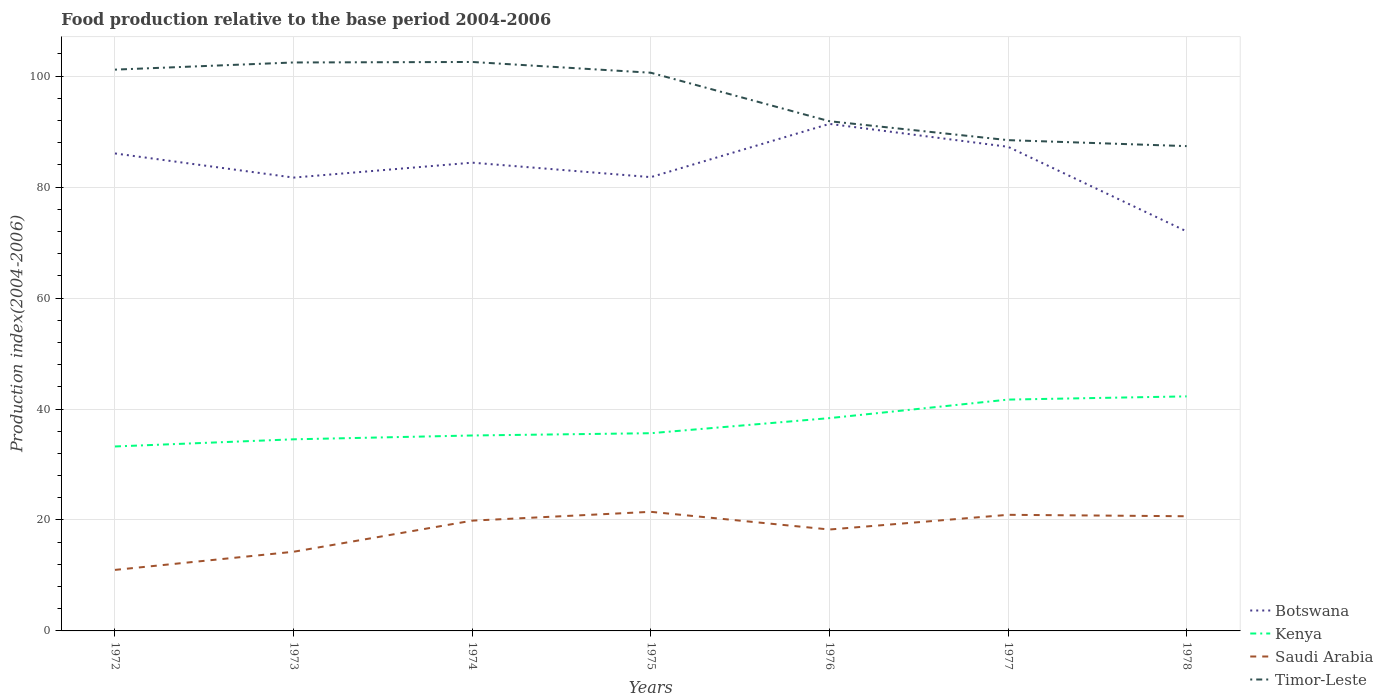Does the line corresponding to Botswana intersect with the line corresponding to Timor-Leste?
Provide a succinct answer. No. Across all years, what is the maximum food production index in Saudi Arabia?
Make the answer very short. 11. What is the total food production index in Saudi Arabia in the graph?
Provide a succinct answer. -0.79. What is the difference between the highest and the second highest food production index in Botswana?
Your answer should be very brief. 19.38. What is the difference between the highest and the lowest food production index in Kenya?
Make the answer very short. 3. Is the food production index in Botswana strictly greater than the food production index in Kenya over the years?
Your answer should be compact. No. What is the difference between two consecutive major ticks on the Y-axis?
Your answer should be compact. 20. Are the values on the major ticks of Y-axis written in scientific E-notation?
Provide a short and direct response. No. Does the graph contain any zero values?
Keep it short and to the point. No. What is the title of the graph?
Provide a succinct answer. Food production relative to the base period 2004-2006. What is the label or title of the Y-axis?
Make the answer very short. Production index(2004-2006). What is the Production index(2004-2006) of Botswana in 1972?
Provide a succinct answer. 86.07. What is the Production index(2004-2006) in Kenya in 1972?
Your response must be concise. 33.25. What is the Production index(2004-2006) in Saudi Arabia in 1972?
Your answer should be very brief. 11. What is the Production index(2004-2006) of Timor-Leste in 1972?
Your response must be concise. 101.18. What is the Production index(2004-2006) of Botswana in 1973?
Your answer should be compact. 81.72. What is the Production index(2004-2006) of Kenya in 1973?
Your response must be concise. 34.54. What is the Production index(2004-2006) of Saudi Arabia in 1973?
Provide a short and direct response. 14.27. What is the Production index(2004-2006) of Timor-Leste in 1973?
Give a very brief answer. 102.47. What is the Production index(2004-2006) of Botswana in 1974?
Provide a short and direct response. 84.41. What is the Production index(2004-2006) in Kenya in 1974?
Give a very brief answer. 35.23. What is the Production index(2004-2006) in Saudi Arabia in 1974?
Offer a terse response. 19.88. What is the Production index(2004-2006) in Timor-Leste in 1974?
Your response must be concise. 102.56. What is the Production index(2004-2006) in Botswana in 1975?
Make the answer very short. 81.8. What is the Production index(2004-2006) of Kenya in 1975?
Offer a very short reply. 35.64. What is the Production index(2004-2006) in Saudi Arabia in 1975?
Provide a succinct answer. 21.47. What is the Production index(2004-2006) in Timor-Leste in 1975?
Make the answer very short. 100.62. What is the Production index(2004-2006) in Botswana in 1976?
Provide a succinct answer. 91.4. What is the Production index(2004-2006) of Kenya in 1976?
Offer a very short reply. 38.36. What is the Production index(2004-2006) of Saudi Arabia in 1976?
Ensure brevity in your answer.  18.28. What is the Production index(2004-2006) in Timor-Leste in 1976?
Keep it short and to the point. 91.88. What is the Production index(2004-2006) in Botswana in 1977?
Give a very brief answer. 87.27. What is the Production index(2004-2006) in Kenya in 1977?
Ensure brevity in your answer.  41.7. What is the Production index(2004-2006) of Saudi Arabia in 1977?
Offer a very short reply. 20.93. What is the Production index(2004-2006) in Timor-Leste in 1977?
Provide a short and direct response. 88.47. What is the Production index(2004-2006) of Botswana in 1978?
Provide a short and direct response. 72.02. What is the Production index(2004-2006) in Kenya in 1978?
Offer a very short reply. 42.28. What is the Production index(2004-2006) in Saudi Arabia in 1978?
Keep it short and to the point. 20.67. What is the Production index(2004-2006) of Timor-Leste in 1978?
Make the answer very short. 87.39. Across all years, what is the maximum Production index(2004-2006) of Botswana?
Offer a terse response. 91.4. Across all years, what is the maximum Production index(2004-2006) in Kenya?
Your response must be concise. 42.28. Across all years, what is the maximum Production index(2004-2006) of Saudi Arabia?
Your answer should be compact. 21.47. Across all years, what is the maximum Production index(2004-2006) in Timor-Leste?
Keep it short and to the point. 102.56. Across all years, what is the minimum Production index(2004-2006) in Botswana?
Give a very brief answer. 72.02. Across all years, what is the minimum Production index(2004-2006) in Kenya?
Keep it short and to the point. 33.25. Across all years, what is the minimum Production index(2004-2006) of Timor-Leste?
Your answer should be compact. 87.39. What is the total Production index(2004-2006) in Botswana in the graph?
Keep it short and to the point. 584.69. What is the total Production index(2004-2006) in Kenya in the graph?
Offer a very short reply. 261. What is the total Production index(2004-2006) in Saudi Arabia in the graph?
Offer a terse response. 126.5. What is the total Production index(2004-2006) in Timor-Leste in the graph?
Offer a terse response. 674.57. What is the difference between the Production index(2004-2006) in Botswana in 1972 and that in 1973?
Ensure brevity in your answer.  4.35. What is the difference between the Production index(2004-2006) in Kenya in 1972 and that in 1973?
Your response must be concise. -1.29. What is the difference between the Production index(2004-2006) of Saudi Arabia in 1972 and that in 1973?
Provide a short and direct response. -3.27. What is the difference between the Production index(2004-2006) of Timor-Leste in 1972 and that in 1973?
Keep it short and to the point. -1.29. What is the difference between the Production index(2004-2006) in Botswana in 1972 and that in 1974?
Keep it short and to the point. 1.66. What is the difference between the Production index(2004-2006) of Kenya in 1972 and that in 1974?
Provide a short and direct response. -1.98. What is the difference between the Production index(2004-2006) in Saudi Arabia in 1972 and that in 1974?
Your response must be concise. -8.88. What is the difference between the Production index(2004-2006) of Timor-Leste in 1972 and that in 1974?
Give a very brief answer. -1.38. What is the difference between the Production index(2004-2006) in Botswana in 1972 and that in 1975?
Make the answer very short. 4.27. What is the difference between the Production index(2004-2006) in Kenya in 1972 and that in 1975?
Keep it short and to the point. -2.39. What is the difference between the Production index(2004-2006) in Saudi Arabia in 1972 and that in 1975?
Your answer should be very brief. -10.47. What is the difference between the Production index(2004-2006) in Timor-Leste in 1972 and that in 1975?
Ensure brevity in your answer.  0.56. What is the difference between the Production index(2004-2006) in Botswana in 1972 and that in 1976?
Your response must be concise. -5.33. What is the difference between the Production index(2004-2006) of Kenya in 1972 and that in 1976?
Keep it short and to the point. -5.11. What is the difference between the Production index(2004-2006) in Saudi Arabia in 1972 and that in 1976?
Provide a short and direct response. -7.28. What is the difference between the Production index(2004-2006) in Botswana in 1972 and that in 1977?
Your answer should be very brief. -1.2. What is the difference between the Production index(2004-2006) in Kenya in 1972 and that in 1977?
Offer a very short reply. -8.45. What is the difference between the Production index(2004-2006) of Saudi Arabia in 1972 and that in 1977?
Your answer should be compact. -9.93. What is the difference between the Production index(2004-2006) of Timor-Leste in 1972 and that in 1977?
Your answer should be very brief. 12.71. What is the difference between the Production index(2004-2006) of Botswana in 1972 and that in 1978?
Provide a succinct answer. 14.05. What is the difference between the Production index(2004-2006) of Kenya in 1972 and that in 1978?
Give a very brief answer. -9.03. What is the difference between the Production index(2004-2006) of Saudi Arabia in 1972 and that in 1978?
Your answer should be compact. -9.67. What is the difference between the Production index(2004-2006) of Timor-Leste in 1972 and that in 1978?
Make the answer very short. 13.79. What is the difference between the Production index(2004-2006) in Botswana in 1973 and that in 1974?
Offer a terse response. -2.69. What is the difference between the Production index(2004-2006) of Kenya in 1973 and that in 1974?
Offer a terse response. -0.69. What is the difference between the Production index(2004-2006) of Saudi Arabia in 1973 and that in 1974?
Offer a terse response. -5.61. What is the difference between the Production index(2004-2006) of Timor-Leste in 1973 and that in 1974?
Give a very brief answer. -0.09. What is the difference between the Production index(2004-2006) in Botswana in 1973 and that in 1975?
Offer a terse response. -0.08. What is the difference between the Production index(2004-2006) of Saudi Arabia in 1973 and that in 1975?
Provide a succinct answer. -7.2. What is the difference between the Production index(2004-2006) of Timor-Leste in 1973 and that in 1975?
Your response must be concise. 1.85. What is the difference between the Production index(2004-2006) of Botswana in 1973 and that in 1976?
Your answer should be compact. -9.68. What is the difference between the Production index(2004-2006) of Kenya in 1973 and that in 1976?
Ensure brevity in your answer.  -3.82. What is the difference between the Production index(2004-2006) in Saudi Arabia in 1973 and that in 1976?
Offer a very short reply. -4.01. What is the difference between the Production index(2004-2006) of Timor-Leste in 1973 and that in 1976?
Provide a succinct answer. 10.59. What is the difference between the Production index(2004-2006) in Botswana in 1973 and that in 1977?
Provide a succinct answer. -5.55. What is the difference between the Production index(2004-2006) of Kenya in 1973 and that in 1977?
Keep it short and to the point. -7.16. What is the difference between the Production index(2004-2006) of Saudi Arabia in 1973 and that in 1977?
Ensure brevity in your answer.  -6.66. What is the difference between the Production index(2004-2006) in Timor-Leste in 1973 and that in 1977?
Keep it short and to the point. 14. What is the difference between the Production index(2004-2006) of Botswana in 1973 and that in 1978?
Provide a short and direct response. 9.7. What is the difference between the Production index(2004-2006) in Kenya in 1973 and that in 1978?
Keep it short and to the point. -7.74. What is the difference between the Production index(2004-2006) of Saudi Arabia in 1973 and that in 1978?
Offer a very short reply. -6.4. What is the difference between the Production index(2004-2006) of Timor-Leste in 1973 and that in 1978?
Provide a short and direct response. 15.08. What is the difference between the Production index(2004-2006) in Botswana in 1974 and that in 1975?
Provide a short and direct response. 2.61. What is the difference between the Production index(2004-2006) of Kenya in 1974 and that in 1975?
Offer a terse response. -0.41. What is the difference between the Production index(2004-2006) in Saudi Arabia in 1974 and that in 1975?
Your answer should be compact. -1.59. What is the difference between the Production index(2004-2006) in Timor-Leste in 1974 and that in 1975?
Give a very brief answer. 1.94. What is the difference between the Production index(2004-2006) in Botswana in 1974 and that in 1976?
Your answer should be compact. -6.99. What is the difference between the Production index(2004-2006) in Kenya in 1974 and that in 1976?
Your response must be concise. -3.13. What is the difference between the Production index(2004-2006) in Timor-Leste in 1974 and that in 1976?
Give a very brief answer. 10.68. What is the difference between the Production index(2004-2006) in Botswana in 1974 and that in 1977?
Provide a succinct answer. -2.86. What is the difference between the Production index(2004-2006) of Kenya in 1974 and that in 1977?
Provide a short and direct response. -6.47. What is the difference between the Production index(2004-2006) of Saudi Arabia in 1974 and that in 1977?
Provide a succinct answer. -1.05. What is the difference between the Production index(2004-2006) of Timor-Leste in 1974 and that in 1977?
Provide a short and direct response. 14.09. What is the difference between the Production index(2004-2006) in Botswana in 1974 and that in 1978?
Offer a very short reply. 12.39. What is the difference between the Production index(2004-2006) of Kenya in 1974 and that in 1978?
Your response must be concise. -7.05. What is the difference between the Production index(2004-2006) of Saudi Arabia in 1974 and that in 1978?
Offer a terse response. -0.79. What is the difference between the Production index(2004-2006) in Timor-Leste in 1974 and that in 1978?
Keep it short and to the point. 15.17. What is the difference between the Production index(2004-2006) of Kenya in 1975 and that in 1976?
Offer a terse response. -2.72. What is the difference between the Production index(2004-2006) of Saudi Arabia in 1975 and that in 1976?
Your answer should be compact. 3.19. What is the difference between the Production index(2004-2006) in Timor-Leste in 1975 and that in 1976?
Give a very brief answer. 8.74. What is the difference between the Production index(2004-2006) of Botswana in 1975 and that in 1977?
Keep it short and to the point. -5.47. What is the difference between the Production index(2004-2006) of Kenya in 1975 and that in 1977?
Your answer should be compact. -6.06. What is the difference between the Production index(2004-2006) of Saudi Arabia in 1975 and that in 1977?
Offer a very short reply. 0.54. What is the difference between the Production index(2004-2006) of Timor-Leste in 1975 and that in 1977?
Ensure brevity in your answer.  12.15. What is the difference between the Production index(2004-2006) of Botswana in 1975 and that in 1978?
Provide a short and direct response. 9.78. What is the difference between the Production index(2004-2006) in Kenya in 1975 and that in 1978?
Ensure brevity in your answer.  -6.64. What is the difference between the Production index(2004-2006) in Saudi Arabia in 1975 and that in 1978?
Keep it short and to the point. 0.8. What is the difference between the Production index(2004-2006) of Timor-Leste in 1975 and that in 1978?
Keep it short and to the point. 13.23. What is the difference between the Production index(2004-2006) of Botswana in 1976 and that in 1977?
Make the answer very short. 4.13. What is the difference between the Production index(2004-2006) of Kenya in 1976 and that in 1977?
Offer a terse response. -3.34. What is the difference between the Production index(2004-2006) in Saudi Arabia in 1976 and that in 1977?
Offer a terse response. -2.65. What is the difference between the Production index(2004-2006) of Timor-Leste in 1976 and that in 1977?
Offer a terse response. 3.41. What is the difference between the Production index(2004-2006) in Botswana in 1976 and that in 1978?
Offer a very short reply. 19.38. What is the difference between the Production index(2004-2006) of Kenya in 1976 and that in 1978?
Your response must be concise. -3.92. What is the difference between the Production index(2004-2006) in Saudi Arabia in 1976 and that in 1978?
Make the answer very short. -2.39. What is the difference between the Production index(2004-2006) of Timor-Leste in 1976 and that in 1978?
Ensure brevity in your answer.  4.49. What is the difference between the Production index(2004-2006) in Botswana in 1977 and that in 1978?
Your response must be concise. 15.25. What is the difference between the Production index(2004-2006) of Kenya in 1977 and that in 1978?
Ensure brevity in your answer.  -0.58. What is the difference between the Production index(2004-2006) of Saudi Arabia in 1977 and that in 1978?
Provide a short and direct response. 0.26. What is the difference between the Production index(2004-2006) in Timor-Leste in 1977 and that in 1978?
Provide a succinct answer. 1.08. What is the difference between the Production index(2004-2006) in Botswana in 1972 and the Production index(2004-2006) in Kenya in 1973?
Provide a short and direct response. 51.53. What is the difference between the Production index(2004-2006) of Botswana in 1972 and the Production index(2004-2006) of Saudi Arabia in 1973?
Your response must be concise. 71.8. What is the difference between the Production index(2004-2006) in Botswana in 1972 and the Production index(2004-2006) in Timor-Leste in 1973?
Your answer should be very brief. -16.4. What is the difference between the Production index(2004-2006) of Kenya in 1972 and the Production index(2004-2006) of Saudi Arabia in 1973?
Keep it short and to the point. 18.98. What is the difference between the Production index(2004-2006) in Kenya in 1972 and the Production index(2004-2006) in Timor-Leste in 1973?
Provide a succinct answer. -69.22. What is the difference between the Production index(2004-2006) of Saudi Arabia in 1972 and the Production index(2004-2006) of Timor-Leste in 1973?
Keep it short and to the point. -91.47. What is the difference between the Production index(2004-2006) of Botswana in 1972 and the Production index(2004-2006) of Kenya in 1974?
Provide a short and direct response. 50.84. What is the difference between the Production index(2004-2006) in Botswana in 1972 and the Production index(2004-2006) in Saudi Arabia in 1974?
Provide a succinct answer. 66.19. What is the difference between the Production index(2004-2006) in Botswana in 1972 and the Production index(2004-2006) in Timor-Leste in 1974?
Offer a very short reply. -16.49. What is the difference between the Production index(2004-2006) of Kenya in 1972 and the Production index(2004-2006) of Saudi Arabia in 1974?
Your response must be concise. 13.37. What is the difference between the Production index(2004-2006) of Kenya in 1972 and the Production index(2004-2006) of Timor-Leste in 1974?
Offer a terse response. -69.31. What is the difference between the Production index(2004-2006) in Saudi Arabia in 1972 and the Production index(2004-2006) in Timor-Leste in 1974?
Your response must be concise. -91.56. What is the difference between the Production index(2004-2006) of Botswana in 1972 and the Production index(2004-2006) of Kenya in 1975?
Ensure brevity in your answer.  50.43. What is the difference between the Production index(2004-2006) in Botswana in 1972 and the Production index(2004-2006) in Saudi Arabia in 1975?
Offer a very short reply. 64.6. What is the difference between the Production index(2004-2006) in Botswana in 1972 and the Production index(2004-2006) in Timor-Leste in 1975?
Your answer should be very brief. -14.55. What is the difference between the Production index(2004-2006) in Kenya in 1972 and the Production index(2004-2006) in Saudi Arabia in 1975?
Provide a short and direct response. 11.78. What is the difference between the Production index(2004-2006) of Kenya in 1972 and the Production index(2004-2006) of Timor-Leste in 1975?
Your response must be concise. -67.37. What is the difference between the Production index(2004-2006) of Saudi Arabia in 1972 and the Production index(2004-2006) of Timor-Leste in 1975?
Provide a succinct answer. -89.62. What is the difference between the Production index(2004-2006) of Botswana in 1972 and the Production index(2004-2006) of Kenya in 1976?
Provide a short and direct response. 47.71. What is the difference between the Production index(2004-2006) in Botswana in 1972 and the Production index(2004-2006) in Saudi Arabia in 1976?
Your response must be concise. 67.79. What is the difference between the Production index(2004-2006) in Botswana in 1972 and the Production index(2004-2006) in Timor-Leste in 1976?
Your answer should be very brief. -5.81. What is the difference between the Production index(2004-2006) in Kenya in 1972 and the Production index(2004-2006) in Saudi Arabia in 1976?
Make the answer very short. 14.97. What is the difference between the Production index(2004-2006) in Kenya in 1972 and the Production index(2004-2006) in Timor-Leste in 1976?
Give a very brief answer. -58.63. What is the difference between the Production index(2004-2006) in Saudi Arabia in 1972 and the Production index(2004-2006) in Timor-Leste in 1976?
Give a very brief answer. -80.88. What is the difference between the Production index(2004-2006) in Botswana in 1972 and the Production index(2004-2006) in Kenya in 1977?
Make the answer very short. 44.37. What is the difference between the Production index(2004-2006) in Botswana in 1972 and the Production index(2004-2006) in Saudi Arabia in 1977?
Make the answer very short. 65.14. What is the difference between the Production index(2004-2006) in Kenya in 1972 and the Production index(2004-2006) in Saudi Arabia in 1977?
Make the answer very short. 12.32. What is the difference between the Production index(2004-2006) in Kenya in 1972 and the Production index(2004-2006) in Timor-Leste in 1977?
Provide a succinct answer. -55.22. What is the difference between the Production index(2004-2006) of Saudi Arabia in 1972 and the Production index(2004-2006) of Timor-Leste in 1977?
Your answer should be very brief. -77.47. What is the difference between the Production index(2004-2006) in Botswana in 1972 and the Production index(2004-2006) in Kenya in 1978?
Your response must be concise. 43.79. What is the difference between the Production index(2004-2006) of Botswana in 1972 and the Production index(2004-2006) of Saudi Arabia in 1978?
Ensure brevity in your answer.  65.4. What is the difference between the Production index(2004-2006) in Botswana in 1972 and the Production index(2004-2006) in Timor-Leste in 1978?
Offer a terse response. -1.32. What is the difference between the Production index(2004-2006) in Kenya in 1972 and the Production index(2004-2006) in Saudi Arabia in 1978?
Your answer should be very brief. 12.58. What is the difference between the Production index(2004-2006) in Kenya in 1972 and the Production index(2004-2006) in Timor-Leste in 1978?
Provide a short and direct response. -54.14. What is the difference between the Production index(2004-2006) in Saudi Arabia in 1972 and the Production index(2004-2006) in Timor-Leste in 1978?
Your answer should be compact. -76.39. What is the difference between the Production index(2004-2006) of Botswana in 1973 and the Production index(2004-2006) of Kenya in 1974?
Give a very brief answer. 46.49. What is the difference between the Production index(2004-2006) in Botswana in 1973 and the Production index(2004-2006) in Saudi Arabia in 1974?
Ensure brevity in your answer.  61.84. What is the difference between the Production index(2004-2006) in Botswana in 1973 and the Production index(2004-2006) in Timor-Leste in 1974?
Provide a short and direct response. -20.84. What is the difference between the Production index(2004-2006) of Kenya in 1973 and the Production index(2004-2006) of Saudi Arabia in 1974?
Your response must be concise. 14.66. What is the difference between the Production index(2004-2006) in Kenya in 1973 and the Production index(2004-2006) in Timor-Leste in 1974?
Offer a very short reply. -68.02. What is the difference between the Production index(2004-2006) of Saudi Arabia in 1973 and the Production index(2004-2006) of Timor-Leste in 1974?
Your answer should be compact. -88.29. What is the difference between the Production index(2004-2006) in Botswana in 1973 and the Production index(2004-2006) in Kenya in 1975?
Give a very brief answer. 46.08. What is the difference between the Production index(2004-2006) in Botswana in 1973 and the Production index(2004-2006) in Saudi Arabia in 1975?
Offer a very short reply. 60.25. What is the difference between the Production index(2004-2006) of Botswana in 1973 and the Production index(2004-2006) of Timor-Leste in 1975?
Your answer should be compact. -18.9. What is the difference between the Production index(2004-2006) of Kenya in 1973 and the Production index(2004-2006) of Saudi Arabia in 1975?
Give a very brief answer. 13.07. What is the difference between the Production index(2004-2006) in Kenya in 1973 and the Production index(2004-2006) in Timor-Leste in 1975?
Keep it short and to the point. -66.08. What is the difference between the Production index(2004-2006) in Saudi Arabia in 1973 and the Production index(2004-2006) in Timor-Leste in 1975?
Your answer should be very brief. -86.35. What is the difference between the Production index(2004-2006) of Botswana in 1973 and the Production index(2004-2006) of Kenya in 1976?
Your answer should be compact. 43.36. What is the difference between the Production index(2004-2006) of Botswana in 1973 and the Production index(2004-2006) of Saudi Arabia in 1976?
Offer a terse response. 63.44. What is the difference between the Production index(2004-2006) of Botswana in 1973 and the Production index(2004-2006) of Timor-Leste in 1976?
Your answer should be compact. -10.16. What is the difference between the Production index(2004-2006) of Kenya in 1973 and the Production index(2004-2006) of Saudi Arabia in 1976?
Provide a short and direct response. 16.26. What is the difference between the Production index(2004-2006) in Kenya in 1973 and the Production index(2004-2006) in Timor-Leste in 1976?
Make the answer very short. -57.34. What is the difference between the Production index(2004-2006) in Saudi Arabia in 1973 and the Production index(2004-2006) in Timor-Leste in 1976?
Provide a succinct answer. -77.61. What is the difference between the Production index(2004-2006) in Botswana in 1973 and the Production index(2004-2006) in Kenya in 1977?
Your answer should be very brief. 40.02. What is the difference between the Production index(2004-2006) in Botswana in 1973 and the Production index(2004-2006) in Saudi Arabia in 1977?
Ensure brevity in your answer.  60.79. What is the difference between the Production index(2004-2006) of Botswana in 1973 and the Production index(2004-2006) of Timor-Leste in 1977?
Make the answer very short. -6.75. What is the difference between the Production index(2004-2006) of Kenya in 1973 and the Production index(2004-2006) of Saudi Arabia in 1977?
Provide a succinct answer. 13.61. What is the difference between the Production index(2004-2006) of Kenya in 1973 and the Production index(2004-2006) of Timor-Leste in 1977?
Ensure brevity in your answer.  -53.93. What is the difference between the Production index(2004-2006) in Saudi Arabia in 1973 and the Production index(2004-2006) in Timor-Leste in 1977?
Provide a succinct answer. -74.2. What is the difference between the Production index(2004-2006) in Botswana in 1973 and the Production index(2004-2006) in Kenya in 1978?
Your answer should be compact. 39.44. What is the difference between the Production index(2004-2006) in Botswana in 1973 and the Production index(2004-2006) in Saudi Arabia in 1978?
Provide a succinct answer. 61.05. What is the difference between the Production index(2004-2006) of Botswana in 1973 and the Production index(2004-2006) of Timor-Leste in 1978?
Make the answer very short. -5.67. What is the difference between the Production index(2004-2006) of Kenya in 1973 and the Production index(2004-2006) of Saudi Arabia in 1978?
Provide a short and direct response. 13.87. What is the difference between the Production index(2004-2006) in Kenya in 1973 and the Production index(2004-2006) in Timor-Leste in 1978?
Your answer should be very brief. -52.85. What is the difference between the Production index(2004-2006) in Saudi Arabia in 1973 and the Production index(2004-2006) in Timor-Leste in 1978?
Make the answer very short. -73.12. What is the difference between the Production index(2004-2006) in Botswana in 1974 and the Production index(2004-2006) in Kenya in 1975?
Provide a succinct answer. 48.77. What is the difference between the Production index(2004-2006) of Botswana in 1974 and the Production index(2004-2006) of Saudi Arabia in 1975?
Your answer should be very brief. 62.94. What is the difference between the Production index(2004-2006) in Botswana in 1974 and the Production index(2004-2006) in Timor-Leste in 1975?
Ensure brevity in your answer.  -16.21. What is the difference between the Production index(2004-2006) in Kenya in 1974 and the Production index(2004-2006) in Saudi Arabia in 1975?
Provide a succinct answer. 13.76. What is the difference between the Production index(2004-2006) in Kenya in 1974 and the Production index(2004-2006) in Timor-Leste in 1975?
Give a very brief answer. -65.39. What is the difference between the Production index(2004-2006) in Saudi Arabia in 1974 and the Production index(2004-2006) in Timor-Leste in 1975?
Your answer should be very brief. -80.74. What is the difference between the Production index(2004-2006) of Botswana in 1974 and the Production index(2004-2006) of Kenya in 1976?
Offer a very short reply. 46.05. What is the difference between the Production index(2004-2006) in Botswana in 1974 and the Production index(2004-2006) in Saudi Arabia in 1976?
Offer a very short reply. 66.13. What is the difference between the Production index(2004-2006) in Botswana in 1974 and the Production index(2004-2006) in Timor-Leste in 1976?
Keep it short and to the point. -7.47. What is the difference between the Production index(2004-2006) of Kenya in 1974 and the Production index(2004-2006) of Saudi Arabia in 1976?
Offer a terse response. 16.95. What is the difference between the Production index(2004-2006) of Kenya in 1974 and the Production index(2004-2006) of Timor-Leste in 1976?
Give a very brief answer. -56.65. What is the difference between the Production index(2004-2006) of Saudi Arabia in 1974 and the Production index(2004-2006) of Timor-Leste in 1976?
Offer a very short reply. -72. What is the difference between the Production index(2004-2006) of Botswana in 1974 and the Production index(2004-2006) of Kenya in 1977?
Provide a succinct answer. 42.71. What is the difference between the Production index(2004-2006) of Botswana in 1974 and the Production index(2004-2006) of Saudi Arabia in 1977?
Your answer should be very brief. 63.48. What is the difference between the Production index(2004-2006) of Botswana in 1974 and the Production index(2004-2006) of Timor-Leste in 1977?
Provide a short and direct response. -4.06. What is the difference between the Production index(2004-2006) in Kenya in 1974 and the Production index(2004-2006) in Saudi Arabia in 1977?
Keep it short and to the point. 14.3. What is the difference between the Production index(2004-2006) in Kenya in 1974 and the Production index(2004-2006) in Timor-Leste in 1977?
Ensure brevity in your answer.  -53.24. What is the difference between the Production index(2004-2006) of Saudi Arabia in 1974 and the Production index(2004-2006) of Timor-Leste in 1977?
Give a very brief answer. -68.59. What is the difference between the Production index(2004-2006) in Botswana in 1974 and the Production index(2004-2006) in Kenya in 1978?
Offer a very short reply. 42.13. What is the difference between the Production index(2004-2006) of Botswana in 1974 and the Production index(2004-2006) of Saudi Arabia in 1978?
Provide a short and direct response. 63.74. What is the difference between the Production index(2004-2006) in Botswana in 1974 and the Production index(2004-2006) in Timor-Leste in 1978?
Make the answer very short. -2.98. What is the difference between the Production index(2004-2006) of Kenya in 1974 and the Production index(2004-2006) of Saudi Arabia in 1978?
Ensure brevity in your answer.  14.56. What is the difference between the Production index(2004-2006) of Kenya in 1974 and the Production index(2004-2006) of Timor-Leste in 1978?
Your response must be concise. -52.16. What is the difference between the Production index(2004-2006) of Saudi Arabia in 1974 and the Production index(2004-2006) of Timor-Leste in 1978?
Provide a succinct answer. -67.51. What is the difference between the Production index(2004-2006) of Botswana in 1975 and the Production index(2004-2006) of Kenya in 1976?
Offer a terse response. 43.44. What is the difference between the Production index(2004-2006) in Botswana in 1975 and the Production index(2004-2006) in Saudi Arabia in 1976?
Provide a short and direct response. 63.52. What is the difference between the Production index(2004-2006) in Botswana in 1975 and the Production index(2004-2006) in Timor-Leste in 1976?
Provide a succinct answer. -10.08. What is the difference between the Production index(2004-2006) of Kenya in 1975 and the Production index(2004-2006) of Saudi Arabia in 1976?
Provide a short and direct response. 17.36. What is the difference between the Production index(2004-2006) of Kenya in 1975 and the Production index(2004-2006) of Timor-Leste in 1976?
Provide a short and direct response. -56.24. What is the difference between the Production index(2004-2006) of Saudi Arabia in 1975 and the Production index(2004-2006) of Timor-Leste in 1976?
Give a very brief answer. -70.41. What is the difference between the Production index(2004-2006) of Botswana in 1975 and the Production index(2004-2006) of Kenya in 1977?
Ensure brevity in your answer.  40.1. What is the difference between the Production index(2004-2006) of Botswana in 1975 and the Production index(2004-2006) of Saudi Arabia in 1977?
Offer a terse response. 60.87. What is the difference between the Production index(2004-2006) in Botswana in 1975 and the Production index(2004-2006) in Timor-Leste in 1977?
Offer a very short reply. -6.67. What is the difference between the Production index(2004-2006) of Kenya in 1975 and the Production index(2004-2006) of Saudi Arabia in 1977?
Your answer should be compact. 14.71. What is the difference between the Production index(2004-2006) of Kenya in 1975 and the Production index(2004-2006) of Timor-Leste in 1977?
Make the answer very short. -52.83. What is the difference between the Production index(2004-2006) of Saudi Arabia in 1975 and the Production index(2004-2006) of Timor-Leste in 1977?
Make the answer very short. -67. What is the difference between the Production index(2004-2006) of Botswana in 1975 and the Production index(2004-2006) of Kenya in 1978?
Keep it short and to the point. 39.52. What is the difference between the Production index(2004-2006) of Botswana in 1975 and the Production index(2004-2006) of Saudi Arabia in 1978?
Your answer should be very brief. 61.13. What is the difference between the Production index(2004-2006) of Botswana in 1975 and the Production index(2004-2006) of Timor-Leste in 1978?
Your answer should be very brief. -5.59. What is the difference between the Production index(2004-2006) of Kenya in 1975 and the Production index(2004-2006) of Saudi Arabia in 1978?
Provide a succinct answer. 14.97. What is the difference between the Production index(2004-2006) of Kenya in 1975 and the Production index(2004-2006) of Timor-Leste in 1978?
Your answer should be compact. -51.75. What is the difference between the Production index(2004-2006) of Saudi Arabia in 1975 and the Production index(2004-2006) of Timor-Leste in 1978?
Provide a short and direct response. -65.92. What is the difference between the Production index(2004-2006) of Botswana in 1976 and the Production index(2004-2006) of Kenya in 1977?
Provide a succinct answer. 49.7. What is the difference between the Production index(2004-2006) of Botswana in 1976 and the Production index(2004-2006) of Saudi Arabia in 1977?
Ensure brevity in your answer.  70.47. What is the difference between the Production index(2004-2006) of Botswana in 1976 and the Production index(2004-2006) of Timor-Leste in 1977?
Ensure brevity in your answer.  2.93. What is the difference between the Production index(2004-2006) of Kenya in 1976 and the Production index(2004-2006) of Saudi Arabia in 1977?
Your answer should be very brief. 17.43. What is the difference between the Production index(2004-2006) of Kenya in 1976 and the Production index(2004-2006) of Timor-Leste in 1977?
Offer a terse response. -50.11. What is the difference between the Production index(2004-2006) of Saudi Arabia in 1976 and the Production index(2004-2006) of Timor-Leste in 1977?
Provide a succinct answer. -70.19. What is the difference between the Production index(2004-2006) of Botswana in 1976 and the Production index(2004-2006) of Kenya in 1978?
Your response must be concise. 49.12. What is the difference between the Production index(2004-2006) in Botswana in 1976 and the Production index(2004-2006) in Saudi Arabia in 1978?
Give a very brief answer. 70.73. What is the difference between the Production index(2004-2006) in Botswana in 1976 and the Production index(2004-2006) in Timor-Leste in 1978?
Provide a succinct answer. 4.01. What is the difference between the Production index(2004-2006) of Kenya in 1976 and the Production index(2004-2006) of Saudi Arabia in 1978?
Keep it short and to the point. 17.69. What is the difference between the Production index(2004-2006) of Kenya in 1976 and the Production index(2004-2006) of Timor-Leste in 1978?
Your response must be concise. -49.03. What is the difference between the Production index(2004-2006) in Saudi Arabia in 1976 and the Production index(2004-2006) in Timor-Leste in 1978?
Give a very brief answer. -69.11. What is the difference between the Production index(2004-2006) of Botswana in 1977 and the Production index(2004-2006) of Kenya in 1978?
Your answer should be compact. 44.99. What is the difference between the Production index(2004-2006) of Botswana in 1977 and the Production index(2004-2006) of Saudi Arabia in 1978?
Your answer should be compact. 66.6. What is the difference between the Production index(2004-2006) in Botswana in 1977 and the Production index(2004-2006) in Timor-Leste in 1978?
Your answer should be compact. -0.12. What is the difference between the Production index(2004-2006) in Kenya in 1977 and the Production index(2004-2006) in Saudi Arabia in 1978?
Offer a very short reply. 21.03. What is the difference between the Production index(2004-2006) of Kenya in 1977 and the Production index(2004-2006) of Timor-Leste in 1978?
Keep it short and to the point. -45.69. What is the difference between the Production index(2004-2006) of Saudi Arabia in 1977 and the Production index(2004-2006) of Timor-Leste in 1978?
Make the answer very short. -66.46. What is the average Production index(2004-2006) in Botswana per year?
Make the answer very short. 83.53. What is the average Production index(2004-2006) of Kenya per year?
Ensure brevity in your answer.  37.29. What is the average Production index(2004-2006) in Saudi Arabia per year?
Offer a terse response. 18.07. What is the average Production index(2004-2006) of Timor-Leste per year?
Ensure brevity in your answer.  96.37. In the year 1972, what is the difference between the Production index(2004-2006) in Botswana and Production index(2004-2006) in Kenya?
Ensure brevity in your answer.  52.82. In the year 1972, what is the difference between the Production index(2004-2006) of Botswana and Production index(2004-2006) of Saudi Arabia?
Make the answer very short. 75.07. In the year 1972, what is the difference between the Production index(2004-2006) in Botswana and Production index(2004-2006) in Timor-Leste?
Give a very brief answer. -15.11. In the year 1972, what is the difference between the Production index(2004-2006) of Kenya and Production index(2004-2006) of Saudi Arabia?
Offer a terse response. 22.25. In the year 1972, what is the difference between the Production index(2004-2006) of Kenya and Production index(2004-2006) of Timor-Leste?
Your response must be concise. -67.93. In the year 1972, what is the difference between the Production index(2004-2006) in Saudi Arabia and Production index(2004-2006) in Timor-Leste?
Provide a succinct answer. -90.18. In the year 1973, what is the difference between the Production index(2004-2006) in Botswana and Production index(2004-2006) in Kenya?
Your answer should be very brief. 47.18. In the year 1973, what is the difference between the Production index(2004-2006) of Botswana and Production index(2004-2006) of Saudi Arabia?
Ensure brevity in your answer.  67.45. In the year 1973, what is the difference between the Production index(2004-2006) in Botswana and Production index(2004-2006) in Timor-Leste?
Give a very brief answer. -20.75. In the year 1973, what is the difference between the Production index(2004-2006) of Kenya and Production index(2004-2006) of Saudi Arabia?
Keep it short and to the point. 20.27. In the year 1973, what is the difference between the Production index(2004-2006) in Kenya and Production index(2004-2006) in Timor-Leste?
Keep it short and to the point. -67.93. In the year 1973, what is the difference between the Production index(2004-2006) in Saudi Arabia and Production index(2004-2006) in Timor-Leste?
Your answer should be compact. -88.2. In the year 1974, what is the difference between the Production index(2004-2006) in Botswana and Production index(2004-2006) in Kenya?
Your answer should be compact. 49.18. In the year 1974, what is the difference between the Production index(2004-2006) of Botswana and Production index(2004-2006) of Saudi Arabia?
Offer a terse response. 64.53. In the year 1974, what is the difference between the Production index(2004-2006) of Botswana and Production index(2004-2006) of Timor-Leste?
Offer a very short reply. -18.15. In the year 1974, what is the difference between the Production index(2004-2006) of Kenya and Production index(2004-2006) of Saudi Arabia?
Your answer should be very brief. 15.35. In the year 1974, what is the difference between the Production index(2004-2006) in Kenya and Production index(2004-2006) in Timor-Leste?
Offer a very short reply. -67.33. In the year 1974, what is the difference between the Production index(2004-2006) of Saudi Arabia and Production index(2004-2006) of Timor-Leste?
Keep it short and to the point. -82.68. In the year 1975, what is the difference between the Production index(2004-2006) of Botswana and Production index(2004-2006) of Kenya?
Provide a succinct answer. 46.16. In the year 1975, what is the difference between the Production index(2004-2006) of Botswana and Production index(2004-2006) of Saudi Arabia?
Give a very brief answer. 60.33. In the year 1975, what is the difference between the Production index(2004-2006) of Botswana and Production index(2004-2006) of Timor-Leste?
Give a very brief answer. -18.82. In the year 1975, what is the difference between the Production index(2004-2006) of Kenya and Production index(2004-2006) of Saudi Arabia?
Offer a very short reply. 14.17. In the year 1975, what is the difference between the Production index(2004-2006) in Kenya and Production index(2004-2006) in Timor-Leste?
Provide a succinct answer. -64.98. In the year 1975, what is the difference between the Production index(2004-2006) of Saudi Arabia and Production index(2004-2006) of Timor-Leste?
Keep it short and to the point. -79.15. In the year 1976, what is the difference between the Production index(2004-2006) of Botswana and Production index(2004-2006) of Kenya?
Ensure brevity in your answer.  53.04. In the year 1976, what is the difference between the Production index(2004-2006) of Botswana and Production index(2004-2006) of Saudi Arabia?
Keep it short and to the point. 73.12. In the year 1976, what is the difference between the Production index(2004-2006) of Botswana and Production index(2004-2006) of Timor-Leste?
Offer a terse response. -0.48. In the year 1976, what is the difference between the Production index(2004-2006) of Kenya and Production index(2004-2006) of Saudi Arabia?
Make the answer very short. 20.08. In the year 1976, what is the difference between the Production index(2004-2006) of Kenya and Production index(2004-2006) of Timor-Leste?
Your response must be concise. -53.52. In the year 1976, what is the difference between the Production index(2004-2006) in Saudi Arabia and Production index(2004-2006) in Timor-Leste?
Offer a very short reply. -73.6. In the year 1977, what is the difference between the Production index(2004-2006) in Botswana and Production index(2004-2006) in Kenya?
Your response must be concise. 45.57. In the year 1977, what is the difference between the Production index(2004-2006) in Botswana and Production index(2004-2006) in Saudi Arabia?
Your answer should be compact. 66.34. In the year 1977, what is the difference between the Production index(2004-2006) of Kenya and Production index(2004-2006) of Saudi Arabia?
Ensure brevity in your answer.  20.77. In the year 1977, what is the difference between the Production index(2004-2006) in Kenya and Production index(2004-2006) in Timor-Leste?
Your answer should be very brief. -46.77. In the year 1977, what is the difference between the Production index(2004-2006) of Saudi Arabia and Production index(2004-2006) of Timor-Leste?
Give a very brief answer. -67.54. In the year 1978, what is the difference between the Production index(2004-2006) of Botswana and Production index(2004-2006) of Kenya?
Ensure brevity in your answer.  29.74. In the year 1978, what is the difference between the Production index(2004-2006) in Botswana and Production index(2004-2006) in Saudi Arabia?
Your answer should be very brief. 51.35. In the year 1978, what is the difference between the Production index(2004-2006) of Botswana and Production index(2004-2006) of Timor-Leste?
Offer a very short reply. -15.37. In the year 1978, what is the difference between the Production index(2004-2006) of Kenya and Production index(2004-2006) of Saudi Arabia?
Make the answer very short. 21.61. In the year 1978, what is the difference between the Production index(2004-2006) in Kenya and Production index(2004-2006) in Timor-Leste?
Provide a succinct answer. -45.11. In the year 1978, what is the difference between the Production index(2004-2006) of Saudi Arabia and Production index(2004-2006) of Timor-Leste?
Offer a terse response. -66.72. What is the ratio of the Production index(2004-2006) in Botswana in 1972 to that in 1973?
Ensure brevity in your answer.  1.05. What is the ratio of the Production index(2004-2006) in Kenya in 1972 to that in 1973?
Your response must be concise. 0.96. What is the ratio of the Production index(2004-2006) in Saudi Arabia in 1972 to that in 1973?
Make the answer very short. 0.77. What is the ratio of the Production index(2004-2006) of Timor-Leste in 1972 to that in 1973?
Your answer should be very brief. 0.99. What is the ratio of the Production index(2004-2006) of Botswana in 1972 to that in 1974?
Give a very brief answer. 1.02. What is the ratio of the Production index(2004-2006) of Kenya in 1972 to that in 1974?
Offer a terse response. 0.94. What is the ratio of the Production index(2004-2006) in Saudi Arabia in 1972 to that in 1974?
Make the answer very short. 0.55. What is the ratio of the Production index(2004-2006) in Timor-Leste in 1972 to that in 1974?
Your answer should be very brief. 0.99. What is the ratio of the Production index(2004-2006) in Botswana in 1972 to that in 1975?
Offer a very short reply. 1.05. What is the ratio of the Production index(2004-2006) of Kenya in 1972 to that in 1975?
Offer a very short reply. 0.93. What is the ratio of the Production index(2004-2006) of Saudi Arabia in 1972 to that in 1975?
Offer a terse response. 0.51. What is the ratio of the Production index(2004-2006) of Timor-Leste in 1972 to that in 1975?
Keep it short and to the point. 1.01. What is the ratio of the Production index(2004-2006) of Botswana in 1972 to that in 1976?
Your answer should be compact. 0.94. What is the ratio of the Production index(2004-2006) in Kenya in 1972 to that in 1976?
Provide a short and direct response. 0.87. What is the ratio of the Production index(2004-2006) in Saudi Arabia in 1972 to that in 1976?
Offer a terse response. 0.6. What is the ratio of the Production index(2004-2006) of Timor-Leste in 1972 to that in 1976?
Keep it short and to the point. 1.1. What is the ratio of the Production index(2004-2006) of Botswana in 1972 to that in 1977?
Provide a succinct answer. 0.99. What is the ratio of the Production index(2004-2006) in Kenya in 1972 to that in 1977?
Ensure brevity in your answer.  0.8. What is the ratio of the Production index(2004-2006) of Saudi Arabia in 1972 to that in 1977?
Ensure brevity in your answer.  0.53. What is the ratio of the Production index(2004-2006) of Timor-Leste in 1972 to that in 1977?
Provide a short and direct response. 1.14. What is the ratio of the Production index(2004-2006) in Botswana in 1972 to that in 1978?
Provide a short and direct response. 1.2. What is the ratio of the Production index(2004-2006) of Kenya in 1972 to that in 1978?
Your response must be concise. 0.79. What is the ratio of the Production index(2004-2006) in Saudi Arabia in 1972 to that in 1978?
Give a very brief answer. 0.53. What is the ratio of the Production index(2004-2006) in Timor-Leste in 1972 to that in 1978?
Ensure brevity in your answer.  1.16. What is the ratio of the Production index(2004-2006) of Botswana in 1973 to that in 1974?
Your response must be concise. 0.97. What is the ratio of the Production index(2004-2006) in Kenya in 1973 to that in 1974?
Provide a succinct answer. 0.98. What is the ratio of the Production index(2004-2006) of Saudi Arabia in 1973 to that in 1974?
Provide a succinct answer. 0.72. What is the ratio of the Production index(2004-2006) of Botswana in 1973 to that in 1975?
Ensure brevity in your answer.  1. What is the ratio of the Production index(2004-2006) in Kenya in 1973 to that in 1975?
Provide a succinct answer. 0.97. What is the ratio of the Production index(2004-2006) in Saudi Arabia in 1973 to that in 1975?
Provide a succinct answer. 0.66. What is the ratio of the Production index(2004-2006) of Timor-Leste in 1973 to that in 1975?
Provide a short and direct response. 1.02. What is the ratio of the Production index(2004-2006) in Botswana in 1973 to that in 1976?
Make the answer very short. 0.89. What is the ratio of the Production index(2004-2006) in Kenya in 1973 to that in 1976?
Keep it short and to the point. 0.9. What is the ratio of the Production index(2004-2006) in Saudi Arabia in 1973 to that in 1976?
Provide a succinct answer. 0.78. What is the ratio of the Production index(2004-2006) in Timor-Leste in 1973 to that in 1976?
Offer a very short reply. 1.12. What is the ratio of the Production index(2004-2006) of Botswana in 1973 to that in 1977?
Provide a succinct answer. 0.94. What is the ratio of the Production index(2004-2006) of Kenya in 1973 to that in 1977?
Offer a very short reply. 0.83. What is the ratio of the Production index(2004-2006) of Saudi Arabia in 1973 to that in 1977?
Keep it short and to the point. 0.68. What is the ratio of the Production index(2004-2006) of Timor-Leste in 1973 to that in 1977?
Make the answer very short. 1.16. What is the ratio of the Production index(2004-2006) in Botswana in 1973 to that in 1978?
Your response must be concise. 1.13. What is the ratio of the Production index(2004-2006) of Kenya in 1973 to that in 1978?
Provide a short and direct response. 0.82. What is the ratio of the Production index(2004-2006) in Saudi Arabia in 1973 to that in 1978?
Offer a very short reply. 0.69. What is the ratio of the Production index(2004-2006) in Timor-Leste in 1973 to that in 1978?
Give a very brief answer. 1.17. What is the ratio of the Production index(2004-2006) in Botswana in 1974 to that in 1975?
Your response must be concise. 1.03. What is the ratio of the Production index(2004-2006) of Saudi Arabia in 1974 to that in 1975?
Your answer should be very brief. 0.93. What is the ratio of the Production index(2004-2006) of Timor-Leste in 1974 to that in 1975?
Ensure brevity in your answer.  1.02. What is the ratio of the Production index(2004-2006) of Botswana in 1974 to that in 1976?
Make the answer very short. 0.92. What is the ratio of the Production index(2004-2006) in Kenya in 1974 to that in 1976?
Make the answer very short. 0.92. What is the ratio of the Production index(2004-2006) of Saudi Arabia in 1974 to that in 1976?
Ensure brevity in your answer.  1.09. What is the ratio of the Production index(2004-2006) of Timor-Leste in 1974 to that in 1976?
Your response must be concise. 1.12. What is the ratio of the Production index(2004-2006) of Botswana in 1974 to that in 1977?
Your response must be concise. 0.97. What is the ratio of the Production index(2004-2006) in Kenya in 1974 to that in 1977?
Offer a very short reply. 0.84. What is the ratio of the Production index(2004-2006) in Saudi Arabia in 1974 to that in 1977?
Ensure brevity in your answer.  0.95. What is the ratio of the Production index(2004-2006) in Timor-Leste in 1974 to that in 1977?
Keep it short and to the point. 1.16. What is the ratio of the Production index(2004-2006) in Botswana in 1974 to that in 1978?
Make the answer very short. 1.17. What is the ratio of the Production index(2004-2006) in Saudi Arabia in 1974 to that in 1978?
Make the answer very short. 0.96. What is the ratio of the Production index(2004-2006) in Timor-Leste in 1974 to that in 1978?
Provide a short and direct response. 1.17. What is the ratio of the Production index(2004-2006) in Botswana in 1975 to that in 1976?
Give a very brief answer. 0.9. What is the ratio of the Production index(2004-2006) in Kenya in 1975 to that in 1976?
Offer a terse response. 0.93. What is the ratio of the Production index(2004-2006) in Saudi Arabia in 1975 to that in 1976?
Provide a short and direct response. 1.17. What is the ratio of the Production index(2004-2006) in Timor-Leste in 1975 to that in 1976?
Your response must be concise. 1.1. What is the ratio of the Production index(2004-2006) in Botswana in 1975 to that in 1977?
Make the answer very short. 0.94. What is the ratio of the Production index(2004-2006) in Kenya in 1975 to that in 1977?
Your response must be concise. 0.85. What is the ratio of the Production index(2004-2006) in Saudi Arabia in 1975 to that in 1977?
Keep it short and to the point. 1.03. What is the ratio of the Production index(2004-2006) in Timor-Leste in 1975 to that in 1977?
Provide a succinct answer. 1.14. What is the ratio of the Production index(2004-2006) in Botswana in 1975 to that in 1978?
Give a very brief answer. 1.14. What is the ratio of the Production index(2004-2006) in Kenya in 1975 to that in 1978?
Offer a very short reply. 0.84. What is the ratio of the Production index(2004-2006) in Saudi Arabia in 1975 to that in 1978?
Your answer should be very brief. 1.04. What is the ratio of the Production index(2004-2006) in Timor-Leste in 1975 to that in 1978?
Your answer should be compact. 1.15. What is the ratio of the Production index(2004-2006) of Botswana in 1976 to that in 1977?
Offer a terse response. 1.05. What is the ratio of the Production index(2004-2006) of Kenya in 1976 to that in 1977?
Your answer should be very brief. 0.92. What is the ratio of the Production index(2004-2006) of Saudi Arabia in 1976 to that in 1977?
Make the answer very short. 0.87. What is the ratio of the Production index(2004-2006) in Botswana in 1976 to that in 1978?
Your response must be concise. 1.27. What is the ratio of the Production index(2004-2006) of Kenya in 1976 to that in 1978?
Make the answer very short. 0.91. What is the ratio of the Production index(2004-2006) in Saudi Arabia in 1976 to that in 1978?
Your response must be concise. 0.88. What is the ratio of the Production index(2004-2006) in Timor-Leste in 1976 to that in 1978?
Offer a very short reply. 1.05. What is the ratio of the Production index(2004-2006) in Botswana in 1977 to that in 1978?
Offer a terse response. 1.21. What is the ratio of the Production index(2004-2006) in Kenya in 1977 to that in 1978?
Your answer should be very brief. 0.99. What is the ratio of the Production index(2004-2006) of Saudi Arabia in 1977 to that in 1978?
Your answer should be very brief. 1.01. What is the ratio of the Production index(2004-2006) of Timor-Leste in 1977 to that in 1978?
Give a very brief answer. 1.01. What is the difference between the highest and the second highest Production index(2004-2006) in Botswana?
Make the answer very short. 4.13. What is the difference between the highest and the second highest Production index(2004-2006) in Kenya?
Your answer should be compact. 0.58. What is the difference between the highest and the second highest Production index(2004-2006) in Saudi Arabia?
Make the answer very short. 0.54. What is the difference between the highest and the second highest Production index(2004-2006) of Timor-Leste?
Provide a succinct answer. 0.09. What is the difference between the highest and the lowest Production index(2004-2006) in Botswana?
Make the answer very short. 19.38. What is the difference between the highest and the lowest Production index(2004-2006) of Kenya?
Offer a very short reply. 9.03. What is the difference between the highest and the lowest Production index(2004-2006) of Saudi Arabia?
Provide a short and direct response. 10.47. What is the difference between the highest and the lowest Production index(2004-2006) of Timor-Leste?
Make the answer very short. 15.17. 